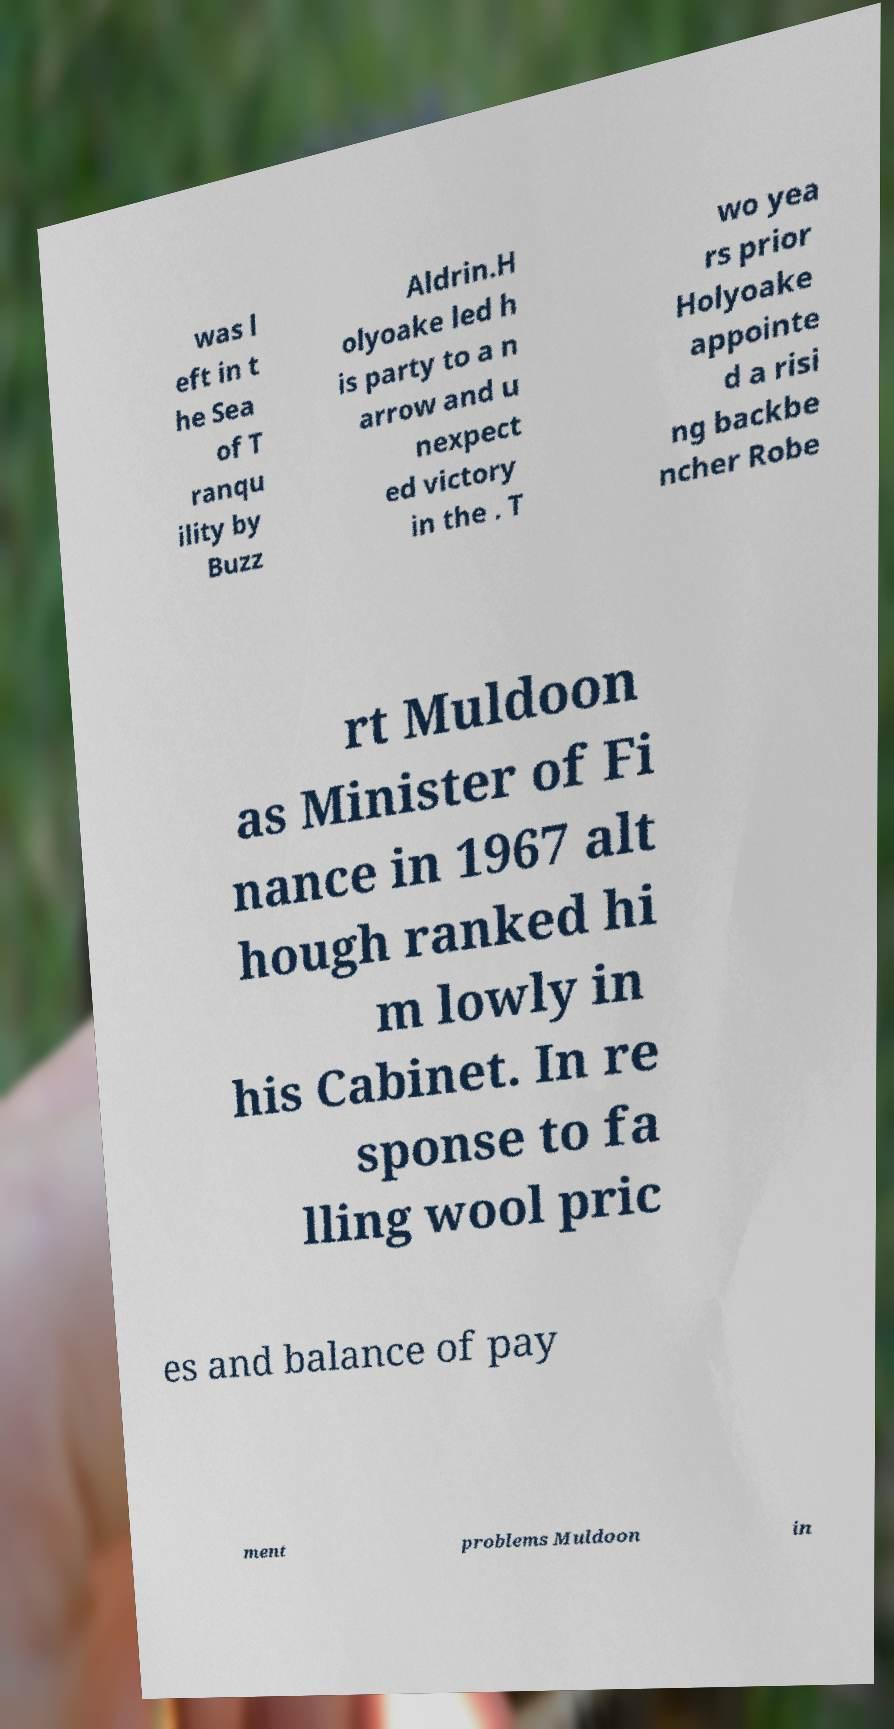Please identify and transcribe the text found in this image. was l eft in t he Sea of T ranqu ility by Buzz Aldrin.H olyoake led h is party to a n arrow and u nexpect ed victory in the . T wo yea rs prior Holyoake appointe d a risi ng backbe ncher Robe rt Muldoon as Minister of Fi nance in 1967 alt hough ranked hi m lowly in his Cabinet. In re sponse to fa lling wool pric es and balance of pay ment problems Muldoon in 